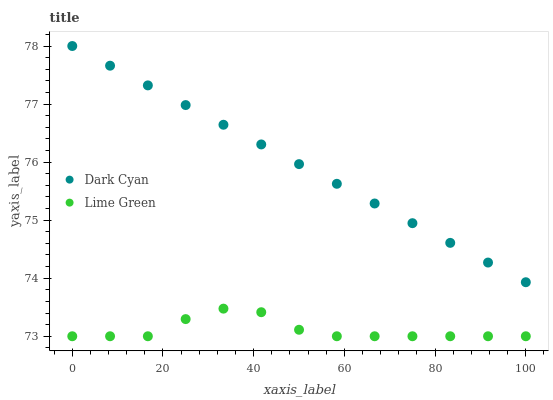Does Lime Green have the minimum area under the curve?
Answer yes or no. Yes. Does Dark Cyan have the maximum area under the curve?
Answer yes or no. Yes. Does Lime Green have the maximum area under the curve?
Answer yes or no. No. Is Dark Cyan the smoothest?
Answer yes or no. Yes. Is Lime Green the roughest?
Answer yes or no. Yes. Is Lime Green the smoothest?
Answer yes or no. No. Does Lime Green have the lowest value?
Answer yes or no. Yes. Does Dark Cyan have the highest value?
Answer yes or no. Yes. Does Lime Green have the highest value?
Answer yes or no. No. Is Lime Green less than Dark Cyan?
Answer yes or no. Yes. Is Dark Cyan greater than Lime Green?
Answer yes or no. Yes. Does Lime Green intersect Dark Cyan?
Answer yes or no. No. 